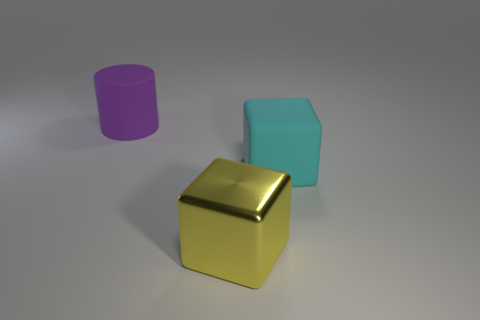Can you tell me which object in the photo is the largest by volume? Based on the visual information, the blue cube appears to be the largest by volume. 